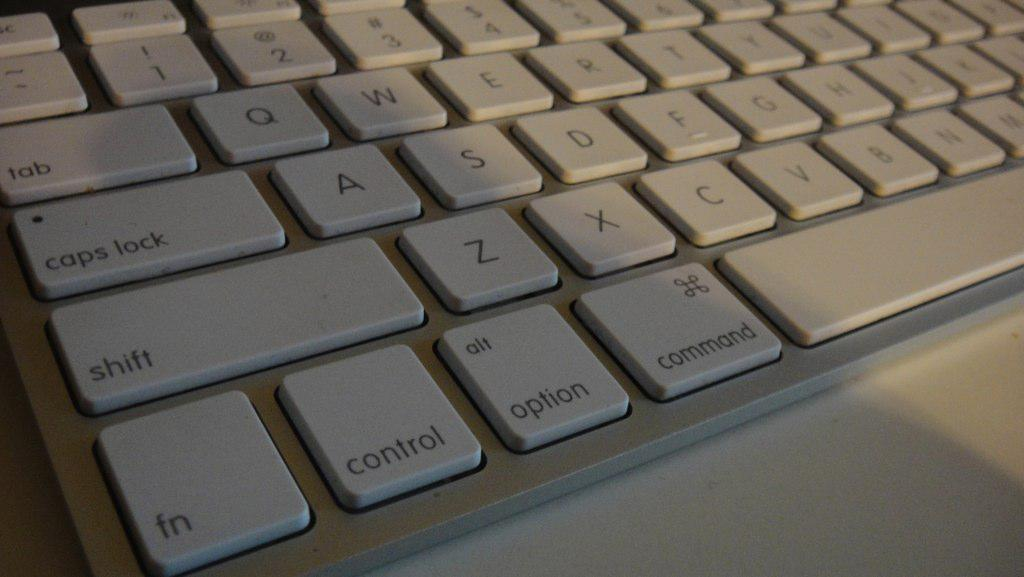<image>
Create a compact narrative representing the image presented. A white keyboard has the control key just to the left of the option key. 